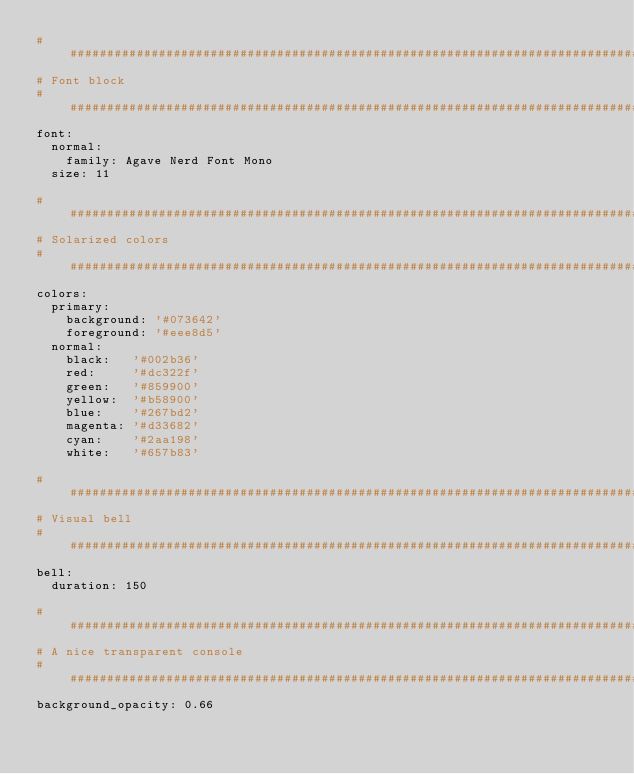<code> <loc_0><loc_0><loc_500><loc_500><_YAML_>################################################################################
# Font block
################################################################################
font:
  normal:
    family: Agave Nerd Font Mono 
  size: 11
  
################################################################################
# Solarized colors
################################################################################
colors:
  primary:
    background: '#073642'
    foreground: '#eee8d5'
  normal:
    black:   '#002b36'
    red:     '#dc322f'
    green:   '#859900'
    yellow:  '#b58900'
    blue:    '#267bd2'
    magenta: '#d33682'
    cyan:    '#2aa198'
    white:   '#657b83'

################################################################################
# Visual bell
################################################################################
bell:
  duration: 150

################################################################################
# A nice transparent console
################################################################################
background_opacity: 0.66
</code> 